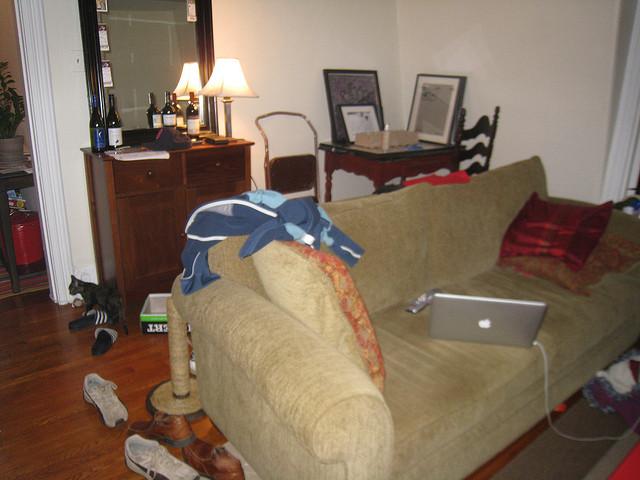What kind of laptop is on the couch?
Write a very short answer. Apple. Is the room tidy?
Give a very brief answer. No. Which animal is in the photo?
Be succinct. Cat. How many chairs are there?
Give a very brief answer. 1. What color is the laptop?
Keep it brief. Silver. What color is the couch?
Write a very short answer. Tan. What is clear in the background?
Keep it brief. Mirror. Is this cat sleeping in a black piece of luggage?
Concise answer only. No. 